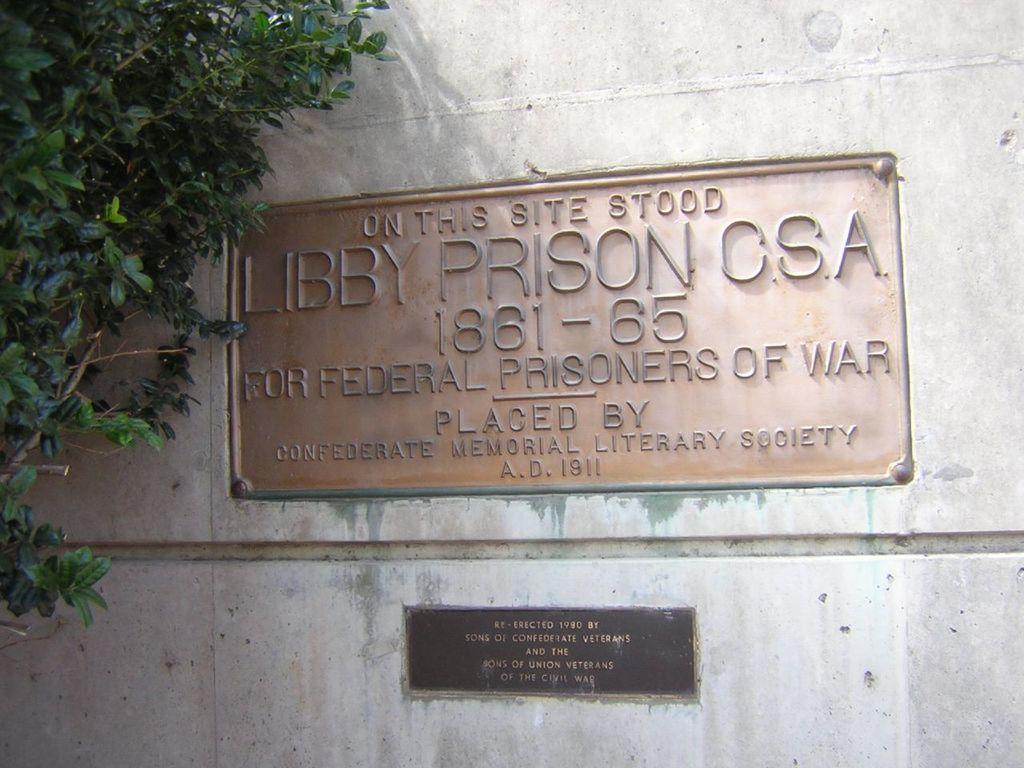Could you give a brief overview of what you see in this image? In this image there is a wall, there are two boards on the wall, there is text on the boards, there is a tree truncated towards the left of the image. 